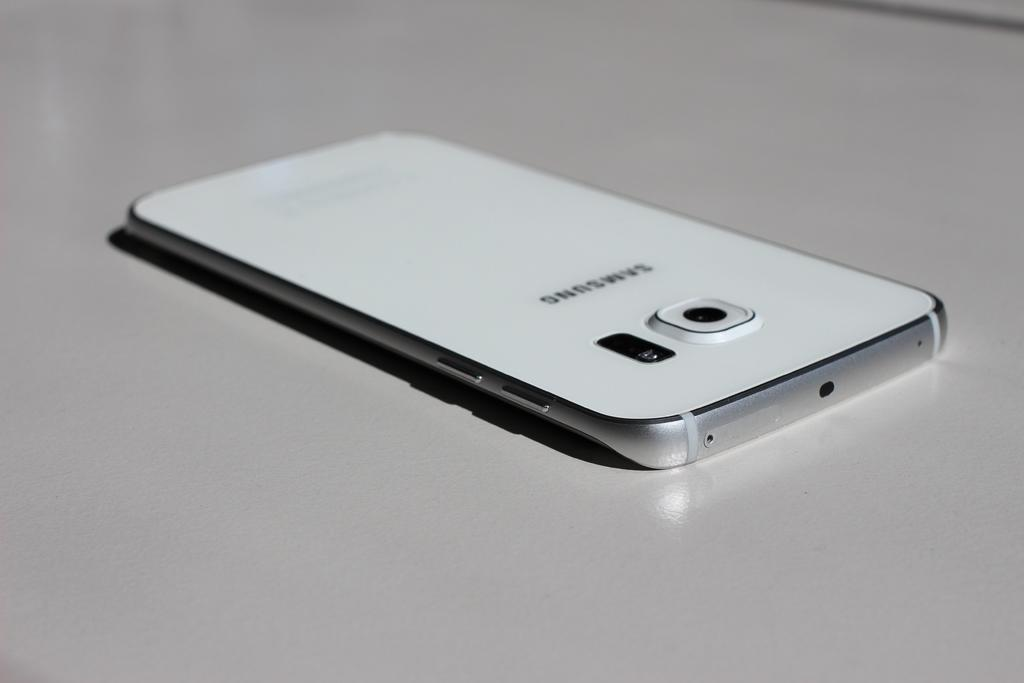<image>
Create a compact narrative representing the image presented. Samsung white cellphone that is laying down on a table 